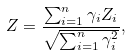Convert formula to latex. <formula><loc_0><loc_0><loc_500><loc_500>Z = \frac { \sum _ { i = 1 } ^ { n } \gamma _ { i } Z _ { i } } { \sqrt { \sum _ { i = 1 } ^ { n } \gamma _ { i } ^ { 2 } } } ,</formula> 